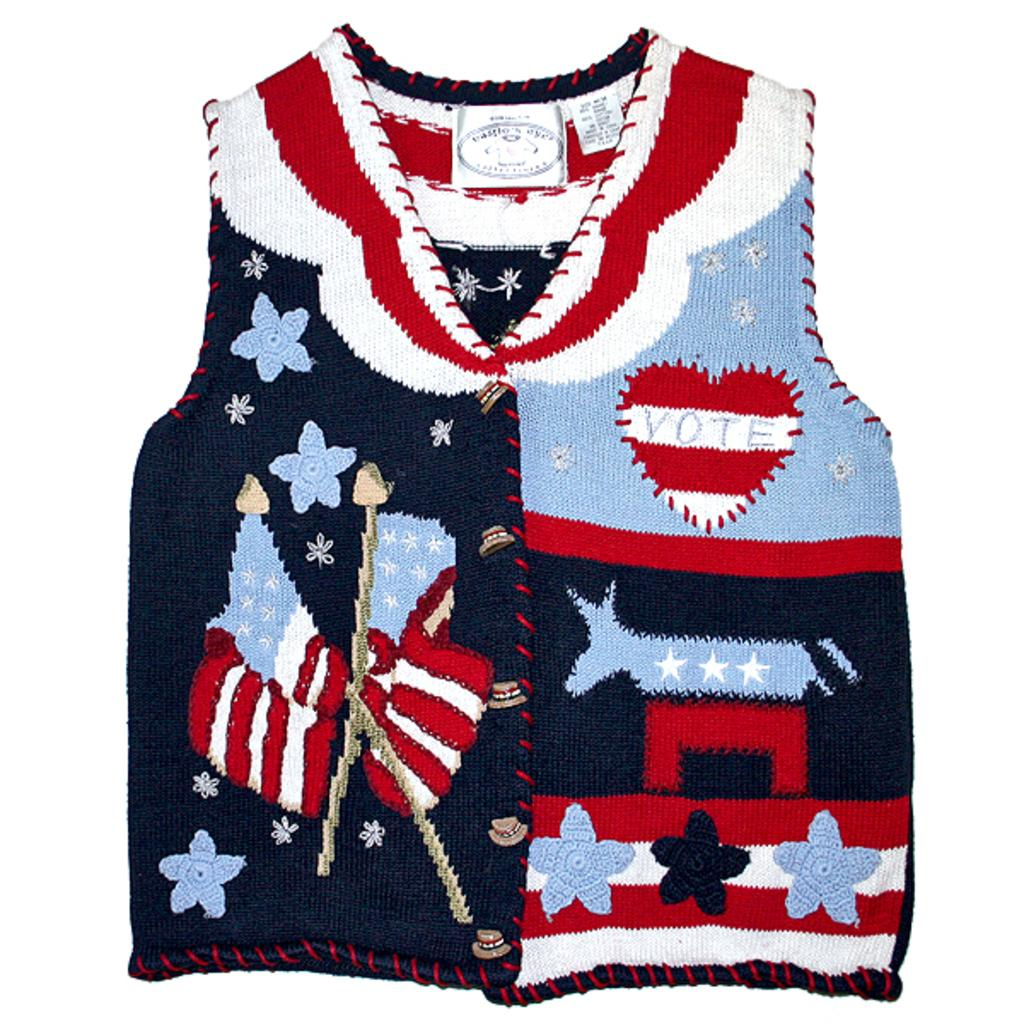<image>
Relay a brief, clear account of the picture shown. Sweater vest that contains designs on it with a heart to vote 